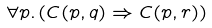<formula> <loc_0><loc_0><loc_500><loc_500>\forall p . \, ( C ( p , q ) \Rightarrow C ( p , r ) )</formula> 